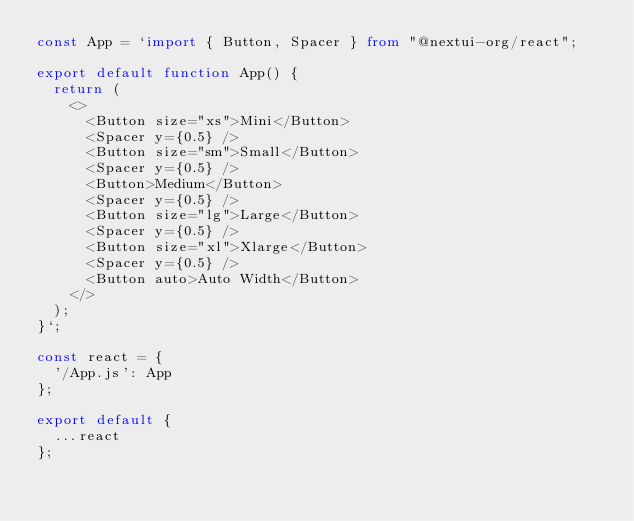<code> <loc_0><loc_0><loc_500><loc_500><_TypeScript_>const App = `import { Button, Spacer } from "@nextui-org/react";

export default function App() {
  return (
    <>
      <Button size="xs">Mini</Button>
      <Spacer y={0.5} />
      <Button size="sm">Small</Button>
      <Spacer y={0.5} />
      <Button>Medium</Button>
      <Spacer y={0.5} />
      <Button size="lg">Large</Button>
      <Spacer y={0.5} />
      <Button size="xl">Xlarge</Button>
      <Spacer y={0.5} />
      <Button auto>Auto Width</Button>
    </>
  );
}`;

const react = {
  '/App.js': App
};

export default {
  ...react
};
</code> 